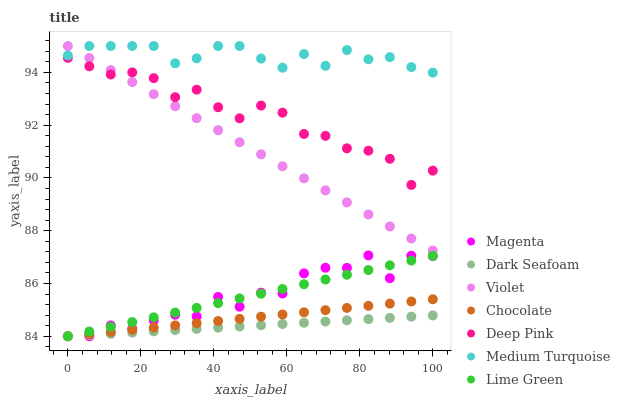Does Dark Seafoam have the minimum area under the curve?
Answer yes or no. Yes. Does Medium Turquoise have the maximum area under the curve?
Answer yes or no. Yes. Does Chocolate have the minimum area under the curve?
Answer yes or no. No. Does Chocolate have the maximum area under the curve?
Answer yes or no. No. Is Lime Green the smoothest?
Answer yes or no. Yes. Is Magenta the roughest?
Answer yes or no. Yes. Is Chocolate the smoothest?
Answer yes or no. No. Is Chocolate the roughest?
Answer yes or no. No. Does Chocolate have the lowest value?
Answer yes or no. Yes. Does Medium Turquoise have the lowest value?
Answer yes or no. No. Does Violet have the highest value?
Answer yes or no. Yes. Does Chocolate have the highest value?
Answer yes or no. No. Is Lime Green less than Violet?
Answer yes or no. Yes. Is Deep Pink greater than Chocolate?
Answer yes or no. Yes. Does Dark Seafoam intersect Lime Green?
Answer yes or no. Yes. Is Dark Seafoam less than Lime Green?
Answer yes or no. No. Is Dark Seafoam greater than Lime Green?
Answer yes or no. No. Does Lime Green intersect Violet?
Answer yes or no. No. 